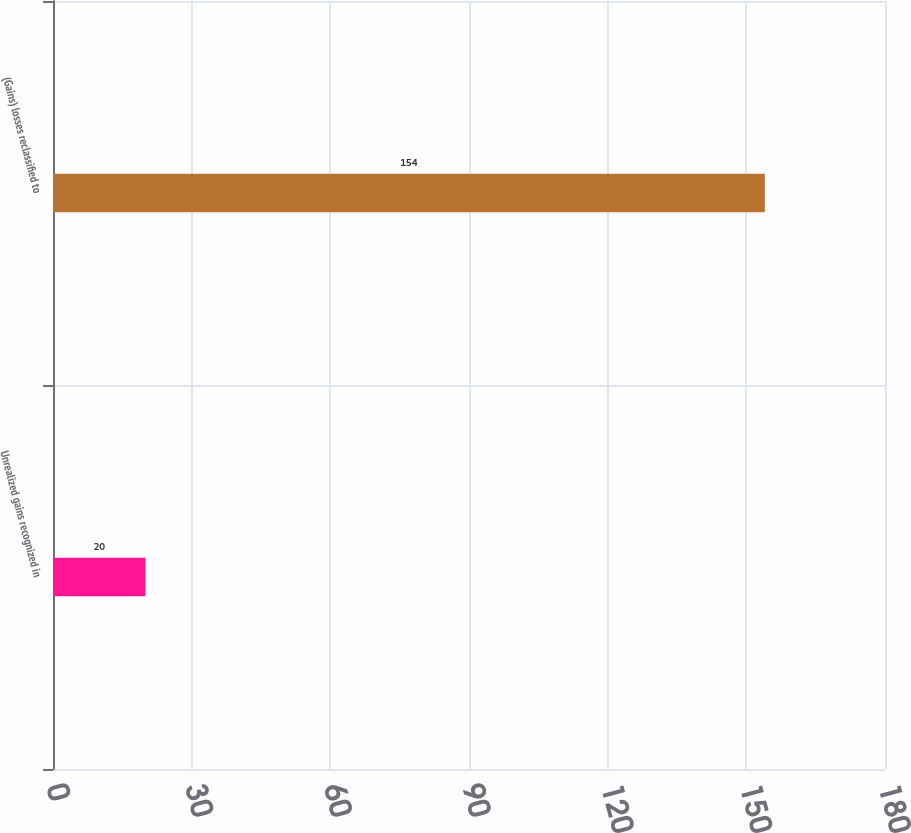<chart> <loc_0><loc_0><loc_500><loc_500><bar_chart><fcel>Unrealized gains recognized in<fcel>(Gains) losses reclassified to<nl><fcel>20<fcel>154<nl></chart> 